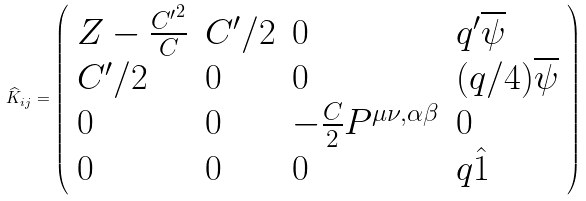<formula> <loc_0><loc_0><loc_500><loc_500>\widehat { K } _ { i j } = \left ( \begin{array} { l l l l } { { Z - { \frac { { C ^ { \prime } } ^ { 2 } } { C } } } } & { { C ^ { \prime } / 2 } } & { 0 } & { { q ^ { \prime } \overline { \psi } } } \\ { { C ^ { \prime } / 2 } } & { 0 } & { 0 } & { { ( q / 4 ) \overline { \psi } } } \\ { 0 } & { 0 } & { { - { \frac { C } { 2 } } P ^ { \mu \nu , \alpha \beta } } } & { 0 } \\ { 0 } & { 0 } & { 0 } & { { q \hat { 1 } } } \end{array} \right )</formula> 